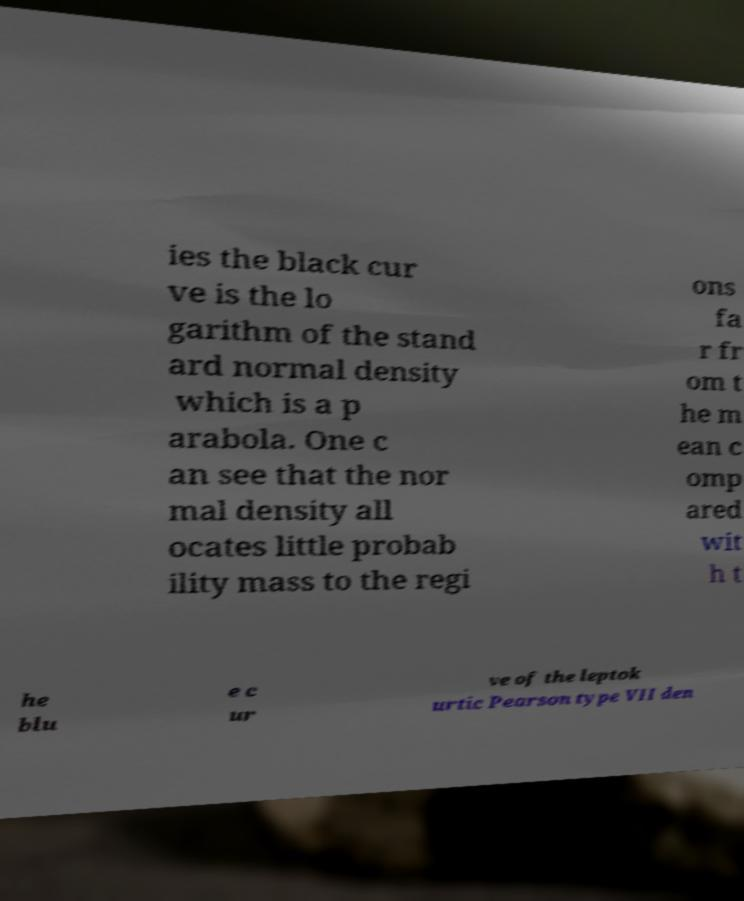There's text embedded in this image that I need extracted. Can you transcribe it verbatim? ies the black cur ve is the lo garithm of the stand ard normal density which is a p arabola. One c an see that the nor mal density all ocates little probab ility mass to the regi ons fa r fr om t he m ean c omp ared wit h t he blu e c ur ve of the leptok urtic Pearson type VII den 